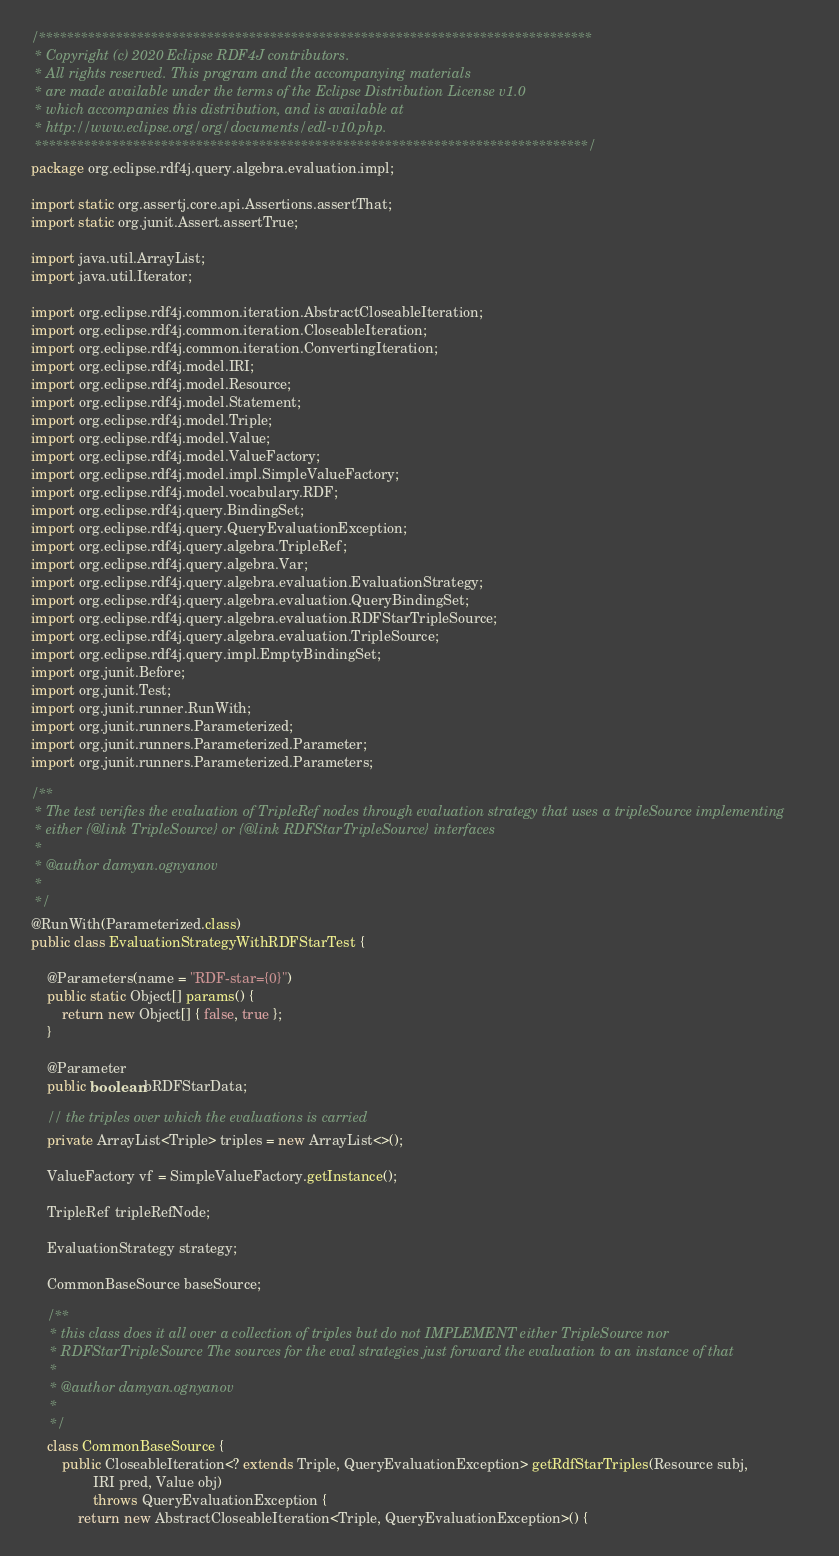Convert code to text. <code><loc_0><loc_0><loc_500><loc_500><_Java_>/*******************************************************************************
 * Copyright (c) 2020 Eclipse RDF4J contributors.
 * All rights reserved. This program and the accompanying materials
 * are made available under the terms of the Eclipse Distribution License v1.0
 * which accompanies this distribution, and is available at
 * http://www.eclipse.org/org/documents/edl-v10.php.
 *******************************************************************************/
package org.eclipse.rdf4j.query.algebra.evaluation.impl;

import static org.assertj.core.api.Assertions.assertThat;
import static org.junit.Assert.assertTrue;

import java.util.ArrayList;
import java.util.Iterator;

import org.eclipse.rdf4j.common.iteration.AbstractCloseableIteration;
import org.eclipse.rdf4j.common.iteration.CloseableIteration;
import org.eclipse.rdf4j.common.iteration.ConvertingIteration;
import org.eclipse.rdf4j.model.IRI;
import org.eclipse.rdf4j.model.Resource;
import org.eclipse.rdf4j.model.Statement;
import org.eclipse.rdf4j.model.Triple;
import org.eclipse.rdf4j.model.Value;
import org.eclipse.rdf4j.model.ValueFactory;
import org.eclipse.rdf4j.model.impl.SimpleValueFactory;
import org.eclipse.rdf4j.model.vocabulary.RDF;
import org.eclipse.rdf4j.query.BindingSet;
import org.eclipse.rdf4j.query.QueryEvaluationException;
import org.eclipse.rdf4j.query.algebra.TripleRef;
import org.eclipse.rdf4j.query.algebra.Var;
import org.eclipse.rdf4j.query.algebra.evaluation.EvaluationStrategy;
import org.eclipse.rdf4j.query.algebra.evaluation.QueryBindingSet;
import org.eclipse.rdf4j.query.algebra.evaluation.RDFStarTripleSource;
import org.eclipse.rdf4j.query.algebra.evaluation.TripleSource;
import org.eclipse.rdf4j.query.impl.EmptyBindingSet;
import org.junit.Before;
import org.junit.Test;
import org.junit.runner.RunWith;
import org.junit.runners.Parameterized;
import org.junit.runners.Parameterized.Parameter;
import org.junit.runners.Parameterized.Parameters;

/**
 * The test verifies the evaluation of TripleRef nodes through evaluation strategy that uses a tripleSource implementing
 * either {@link TripleSource} or {@link RDFStarTripleSource} interfaces
 *
 * @author damyan.ognyanov
 *
 */
@RunWith(Parameterized.class)
public class EvaluationStrategyWithRDFStarTest {

	@Parameters(name = "RDF-star={0}")
	public static Object[] params() {
		return new Object[] { false, true };
	}

	@Parameter
	public boolean bRDFStarData;

	// the triples over which the evaluations is carried
	private ArrayList<Triple> triples = new ArrayList<>();

	ValueFactory vf = SimpleValueFactory.getInstance();

	TripleRef tripleRefNode;

	EvaluationStrategy strategy;

	CommonBaseSource baseSource;

	/**
	 * this class does it all over a collection of triples but do not IMPLEMENT either TripleSource nor
	 * RDFStarTripleSource The sources for the eval strategies just forward the evaluation to an instance of that
	 *
	 * @author damyan.ognyanov
	 *
	 */
	class CommonBaseSource {
		public CloseableIteration<? extends Triple, QueryEvaluationException> getRdfStarTriples(Resource subj,
				IRI pred, Value obj)
				throws QueryEvaluationException {
			return new AbstractCloseableIteration<Triple, QueryEvaluationException>() {</code> 